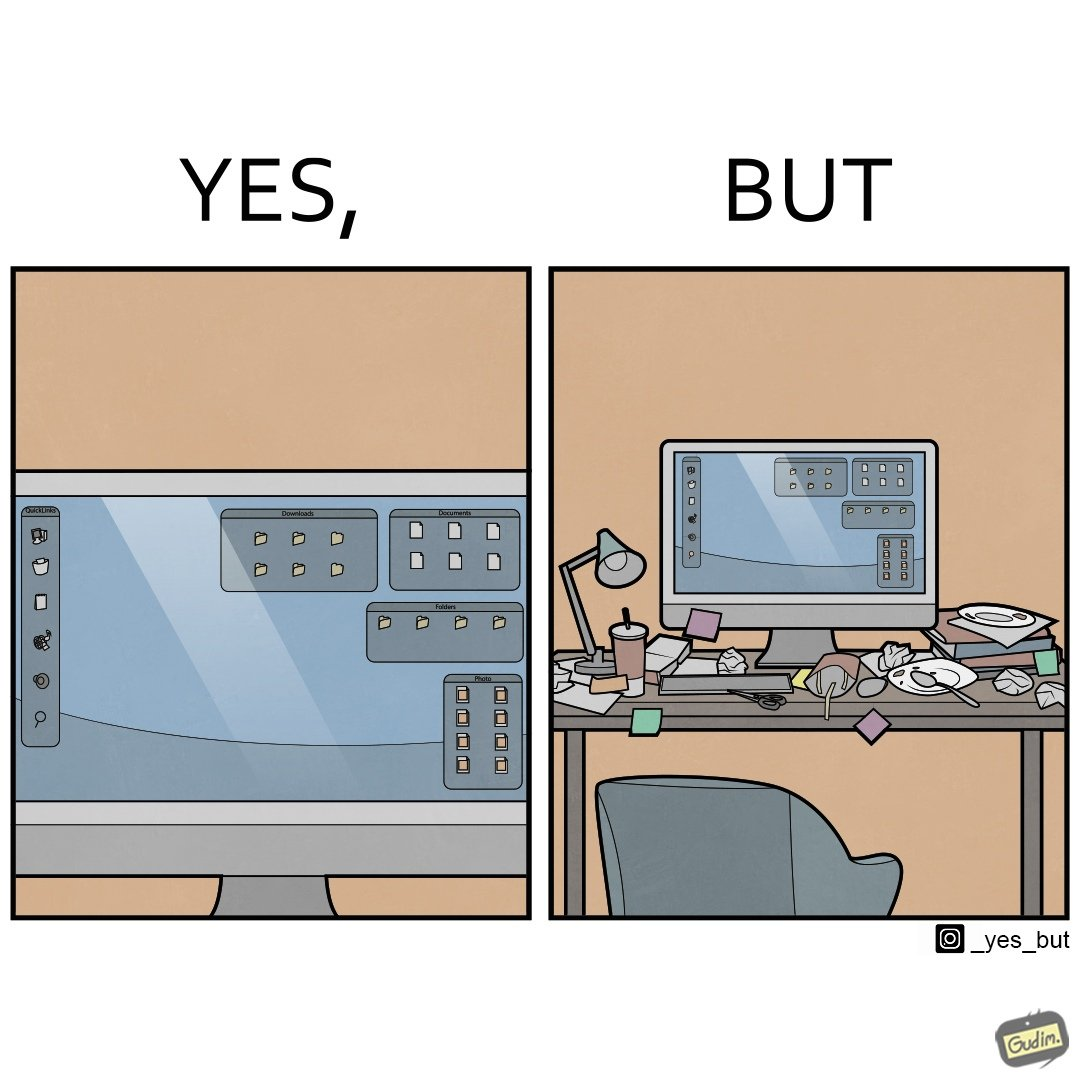Is this a satirical image? Yes, this image is satirical. 